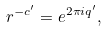Convert formula to latex. <formula><loc_0><loc_0><loc_500><loc_500>r ^ { - c ^ { \prime } } = e ^ { 2 \pi i q ^ { \prime } } ,</formula> 